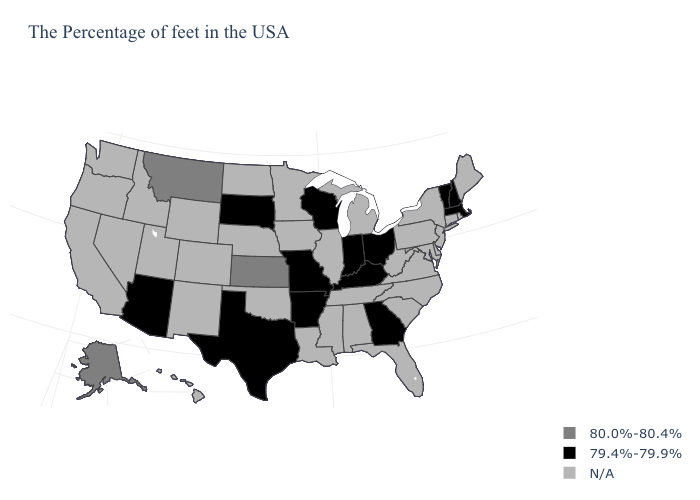What is the value of North Dakota?
Short answer required. N/A. What is the value of Connecticut?
Give a very brief answer. N/A. Does Kentucky have the lowest value in the USA?
Concise answer only. Yes. Name the states that have a value in the range N/A?
Short answer required. Maine, Rhode Island, Connecticut, New York, New Jersey, Delaware, Maryland, Pennsylvania, Virginia, North Carolina, South Carolina, West Virginia, Florida, Michigan, Alabama, Tennessee, Illinois, Mississippi, Louisiana, Minnesota, Iowa, Nebraska, Oklahoma, North Dakota, Wyoming, Colorado, New Mexico, Utah, Idaho, Nevada, California, Washington, Oregon, Hawaii. Is the legend a continuous bar?
Give a very brief answer. No. What is the highest value in the USA?
Answer briefly. 80.0%-80.4%. Does the first symbol in the legend represent the smallest category?
Keep it brief. No. Name the states that have a value in the range 79.4%-79.9%?
Be succinct. Massachusetts, New Hampshire, Vermont, Ohio, Georgia, Kentucky, Indiana, Wisconsin, Missouri, Arkansas, Texas, South Dakota, Arizona. Which states have the lowest value in the USA?
Be succinct. Massachusetts, New Hampshire, Vermont, Ohio, Georgia, Kentucky, Indiana, Wisconsin, Missouri, Arkansas, Texas, South Dakota, Arizona. Which states hav the highest value in the Northeast?
Short answer required. Massachusetts, New Hampshire, Vermont. Name the states that have a value in the range 79.4%-79.9%?
Short answer required. Massachusetts, New Hampshire, Vermont, Ohio, Georgia, Kentucky, Indiana, Wisconsin, Missouri, Arkansas, Texas, South Dakota, Arizona. What is the highest value in the Northeast ?
Give a very brief answer. 79.4%-79.9%. 